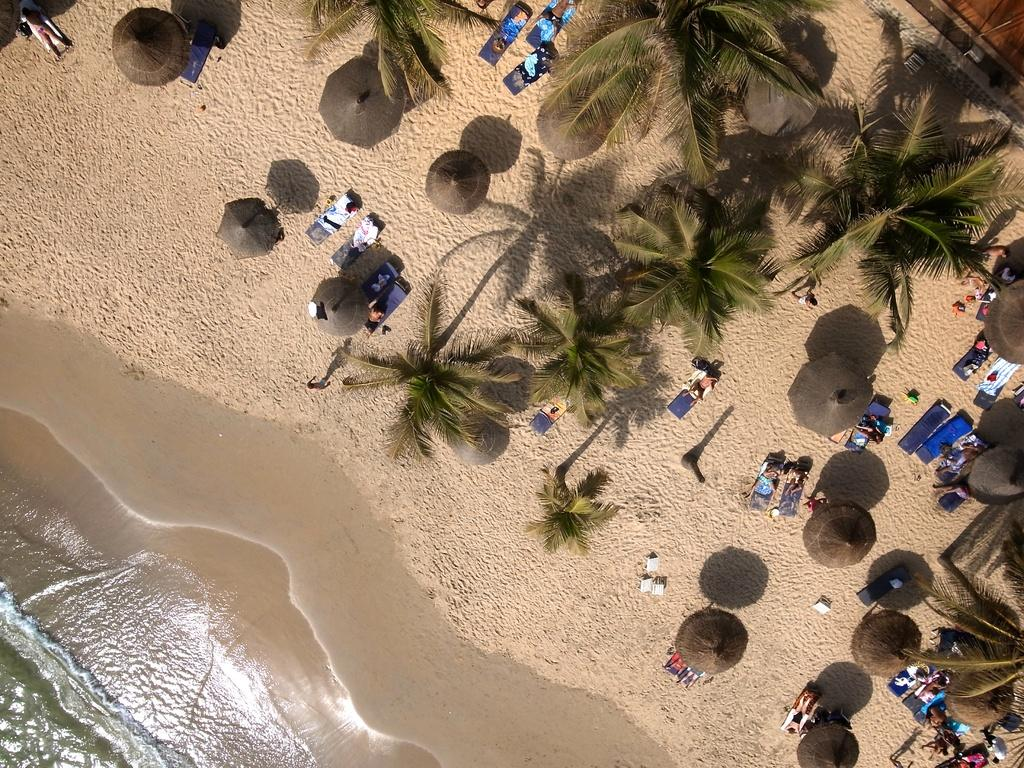How many people are in the image? There is a group of people in the image. What are the people doing in the image? The people are lying on chairs in the image. Where are the chairs located? The chairs are located on a sea shore in the image. What else can be seen in the background of the image? There is a group of trees, poles, outdoor umbrellas, and huts in the image. What is visible in the image besides the land-based objects? The water is visible in the image. Which direction is the van facing in the image? There is no van present in the image. What type of government is responsible for the maintenance of the sea shore in the image? The image does not provide information about the government responsible for the sea shore. 